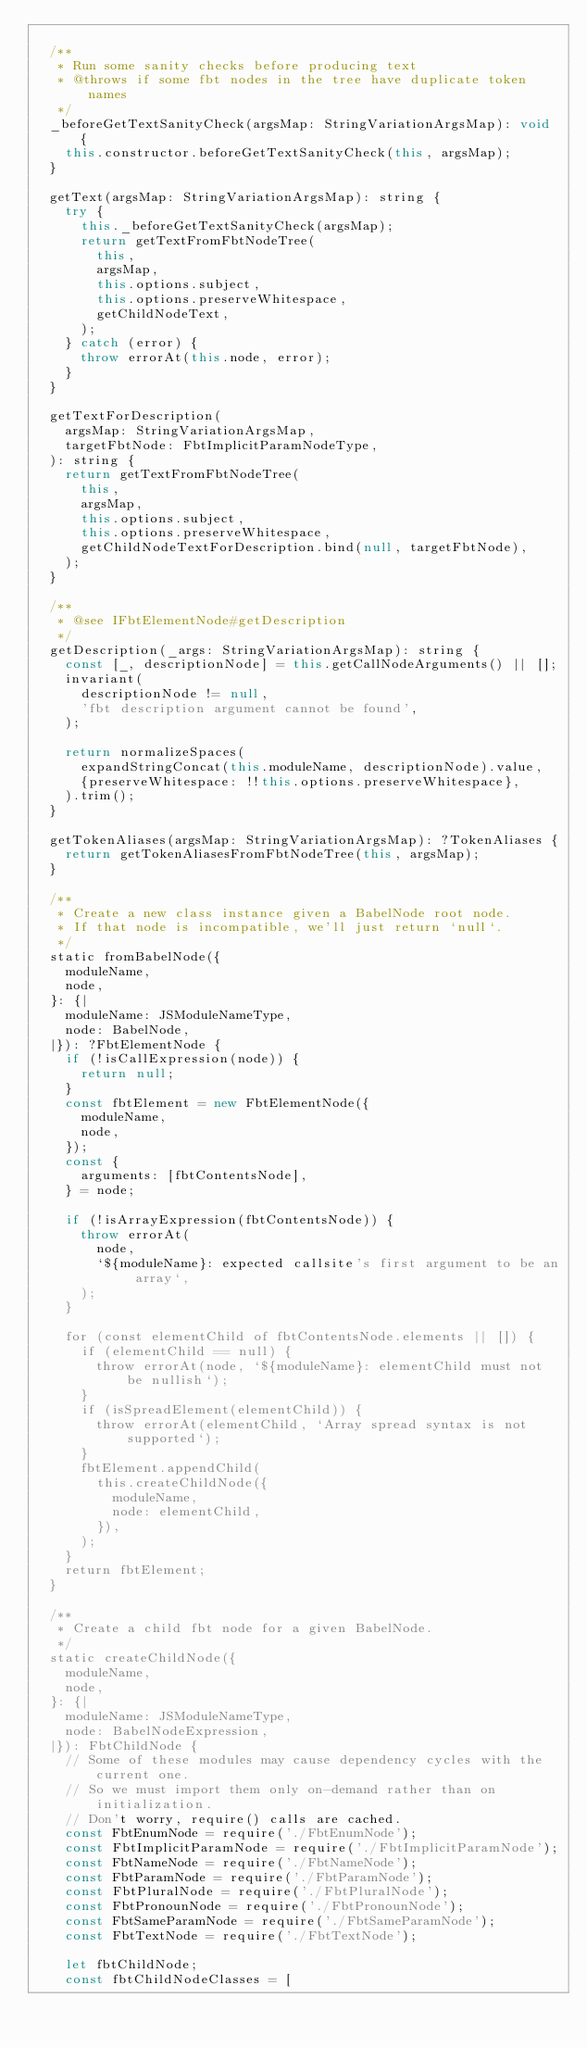Convert code to text. <code><loc_0><loc_0><loc_500><loc_500><_JavaScript_>
  /**
   * Run some sanity checks before producing text
   * @throws if some fbt nodes in the tree have duplicate token names
   */
  _beforeGetTextSanityCheck(argsMap: StringVariationArgsMap): void {
    this.constructor.beforeGetTextSanityCheck(this, argsMap);
  }

  getText(argsMap: StringVariationArgsMap): string {
    try {
      this._beforeGetTextSanityCheck(argsMap);
      return getTextFromFbtNodeTree(
        this,
        argsMap,
        this.options.subject,
        this.options.preserveWhitespace,
        getChildNodeText,
      );
    } catch (error) {
      throw errorAt(this.node, error);
    }
  }

  getTextForDescription(
    argsMap: StringVariationArgsMap,
    targetFbtNode: FbtImplicitParamNodeType,
  ): string {
    return getTextFromFbtNodeTree(
      this,
      argsMap,
      this.options.subject,
      this.options.preserveWhitespace,
      getChildNodeTextForDescription.bind(null, targetFbtNode),
    );
  }

  /**
   * @see IFbtElementNode#getDescription
   */
  getDescription(_args: StringVariationArgsMap): string {
    const [_, descriptionNode] = this.getCallNodeArguments() || [];
    invariant(
      descriptionNode != null,
      'fbt description argument cannot be found',
    );

    return normalizeSpaces(
      expandStringConcat(this.moduleName, descriptionNode).value,
      {preserveWhitespace: !!this.options.preserveWhitespace},
    ).trim();
  }

  getTokenAliases(argsMap: StringVariationArgsMap): ?TokenAliases {
    return getTokenAliasesFromFbtNodeTree(this, argsMap);
  }

  /**
   * Create a new class instance given a BabelNode root node.
   * If that node is incompatible, we'll just return `null`.
   */
  static fromBabelNode({
    moduleName,
    node,
  }: {|
    moduleName: JSModuleNameType,
    node: BabelNode,
  |}): ?FbtElementNode {
    if (!isCallExpression(node)) {
      return null;
    }
    const fbtElement = new FbtElementNode({
      moduleName,
      node,
    });
    const {
      arguments: [fbtContentsNode],
    } = node;

    if (!isArrayExpression(fbtContentsNode)) {
      throw errorAt(
        node,
        `${moduleName}: expected callsite's first argument to be an array`,
      );
    }

    for (const elementChild of fbtContentsNode.elements || []) {
      if (elementChild == null) {
        throw errorAt(node, `${moduleName}: elementChild must not be nullish`);
      }
      if (isSpreadElement(elementChild)) {
        throw errorAt(elementChild, `Array spread syntax is not supported`);
      }
      fbtElement.appendChild(
        this.createChildNode({
          moduleName,
          node: elementChild,
        }),
      );
    }
    return fbtElement;
  }

  /**
   * Create a child fbt node for a given BabelNode.
   */
  static createChildNode({
    moduleName,
    node,
  }: {|
    moduleName: JSModuleNameType,
    node: BabelNodeExpression,
  |}): FbtChildNode {
    // Some of these modules may cause dependency cycles with the current one.
    // So we must import them only on-demand rather than on initialization.
    // Don't worry, require() calls are cached.
    const FbtEnumNode = require('./FbtEnumNode');
    const FbtImplicitParamNode = require('./FbtImplicitParamNode');
    const FbtNameNode = require('./FbtNameNode');
    const FbtParamNode = require('./FbtParamNode');
    const FbtPluralNode = require('./FbtPluralNode');
    const FbtPronounNode = require('./FbtPronounNode');
    const FbtSameParamNode = require('./FbtSameParamNode');
    const FbtTextNode = require('./FbtTextNode');

    let fbtChildNode;
    const fbtChildNodeClasses = [</code> 